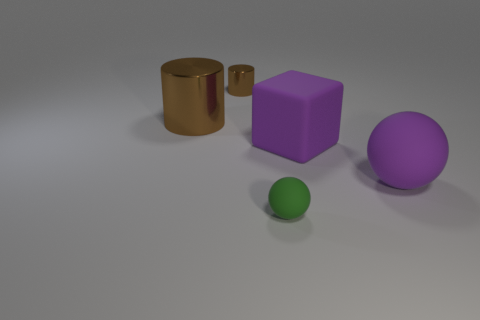There is a large block; does it have the same color as the ball that is to the right of the small green rubber sphere?
Your answer should be very brief. Yes. What number of things are the same size as the green matte ball?
Ensure brevity in your answer.  1. How many gray objects are either objects or cylinders?
Offer a terse response. 0. Is the number of big blocks left of the small ball the same as the number of small green metal objects?
Offer a terse response. Yes. There is a purple rubber object in front of the big purple block; what size is it?
Ensure brevity in your answer.  Large. What number of shiny objects have the same shape as the tiny green rubber object?
Your answer should be compact. 0. The object that is both left of the large block and right of the tiny brown object is made of what material?
Your answer should be very brief. Rubber. Is the material of the big cylinder the same as the small cylinder?
Your answer should be compact. Yes. What number of green things are there?
Ensure brevity in your answer.  1. What is the color of the sphere that is to the left of the rubber ball to the right of the rubber object left of the big cube?
Your answer should be compact. Green. 